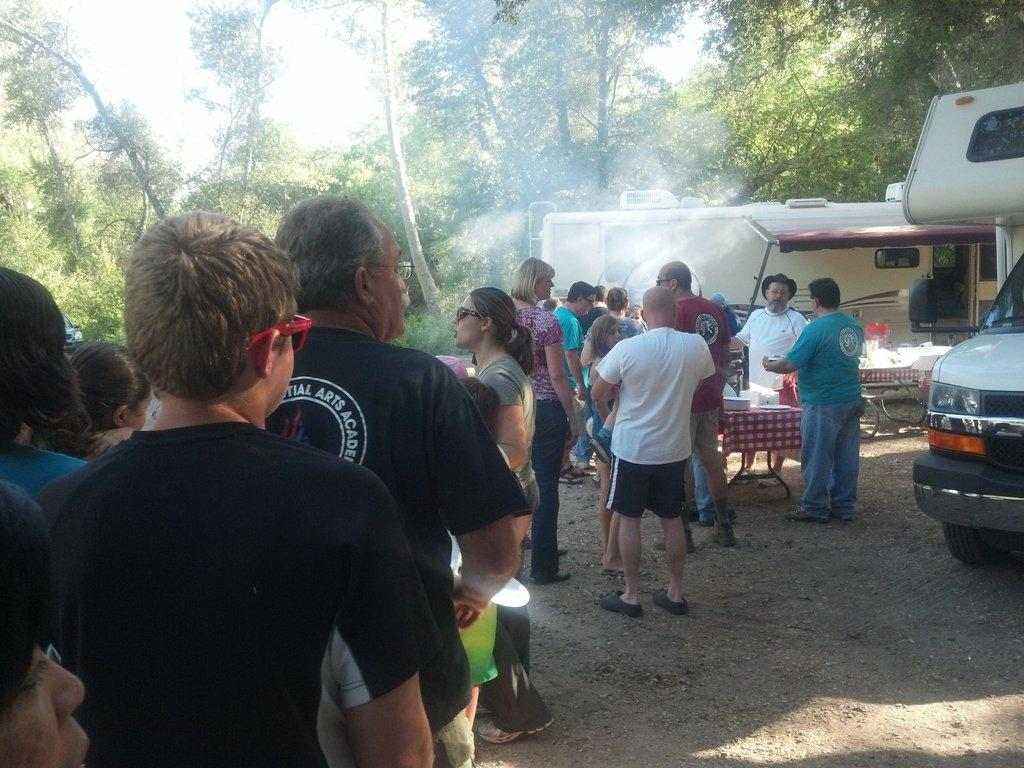What can be seen in the image involving people? There are people standing in the image. What is on the table in the image? There is a table with objects on it in the image. What type of mobile food vendors are present in the image? Food trucks are visible in the image. What natural elements can be seen in the background of the image? There are trees and the sky visible in the background of the image. What type of music is being played by the trees in the background of the image? There is no music being played by the trees in the background of the image. In which direction are the people standing in the image facing? The provided facts do not specify the position or direction the people are facing. 